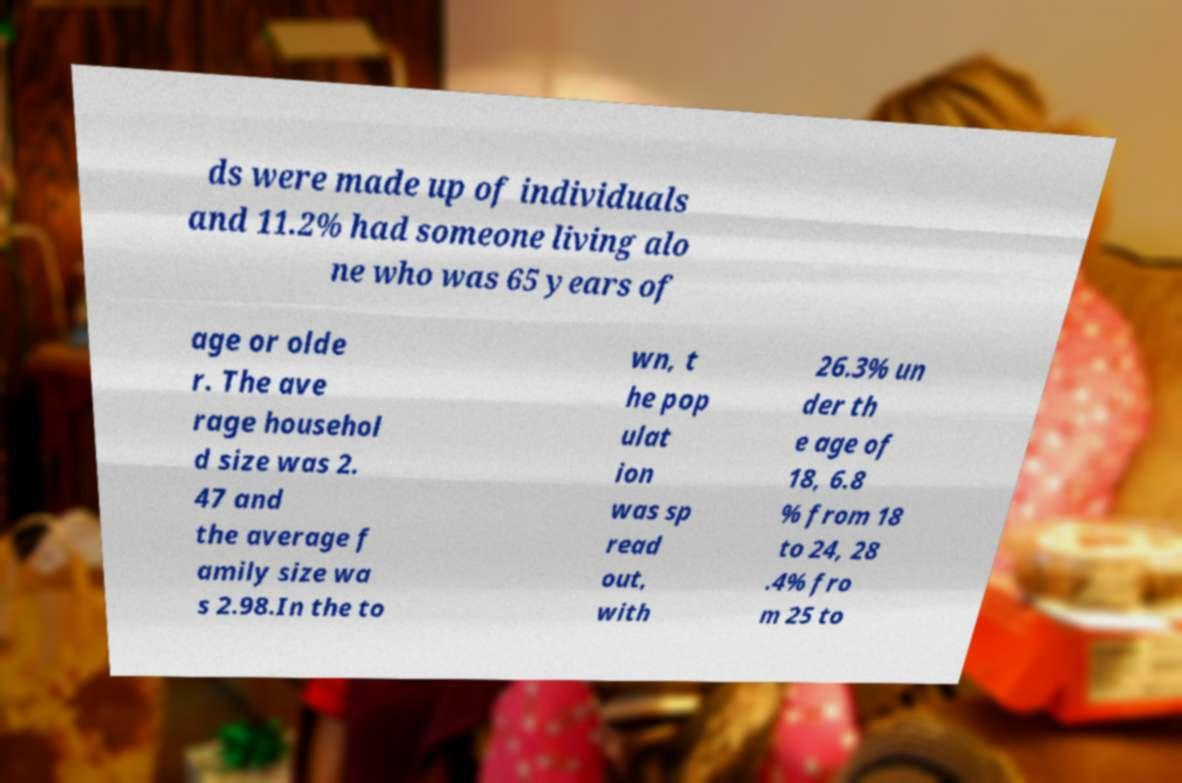For documentation purposes, I need the text within this image transcribed. Could you provide that? ds were made up of individuals and 11.2% had someone living alo ne who was 65 years of age or olde r. The ave rage househol d size was 2. 47 and the average f amily size wa s 2.98.In the to wn, t he pop ulat ion was sp read out, with 26.3% un der th e age of 18, 6.8 % from 18 to 24, 28 .4% fro m 25 to 